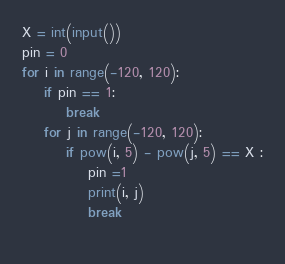Convert code to text. <code><loc_0><loc_0><loc_500><loc_500><_Python_>X = int(input())
pin = 0
for i in range(-120, 120):
    if pin == 1:
        break
    for j in range(-120, 120):
        if pow(i, 5) - pow(j, 5) == X :
            pin =1
            print(i, j)
            break
            </code> 